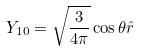Convert formula to latex. <formula><loc_0><loc_0><loc_500><loc_500>Y _ { 1 0 } = \sqrt { \frac { 3 } { 4 \pi } } \cos \theta \hat { r }</formula> 